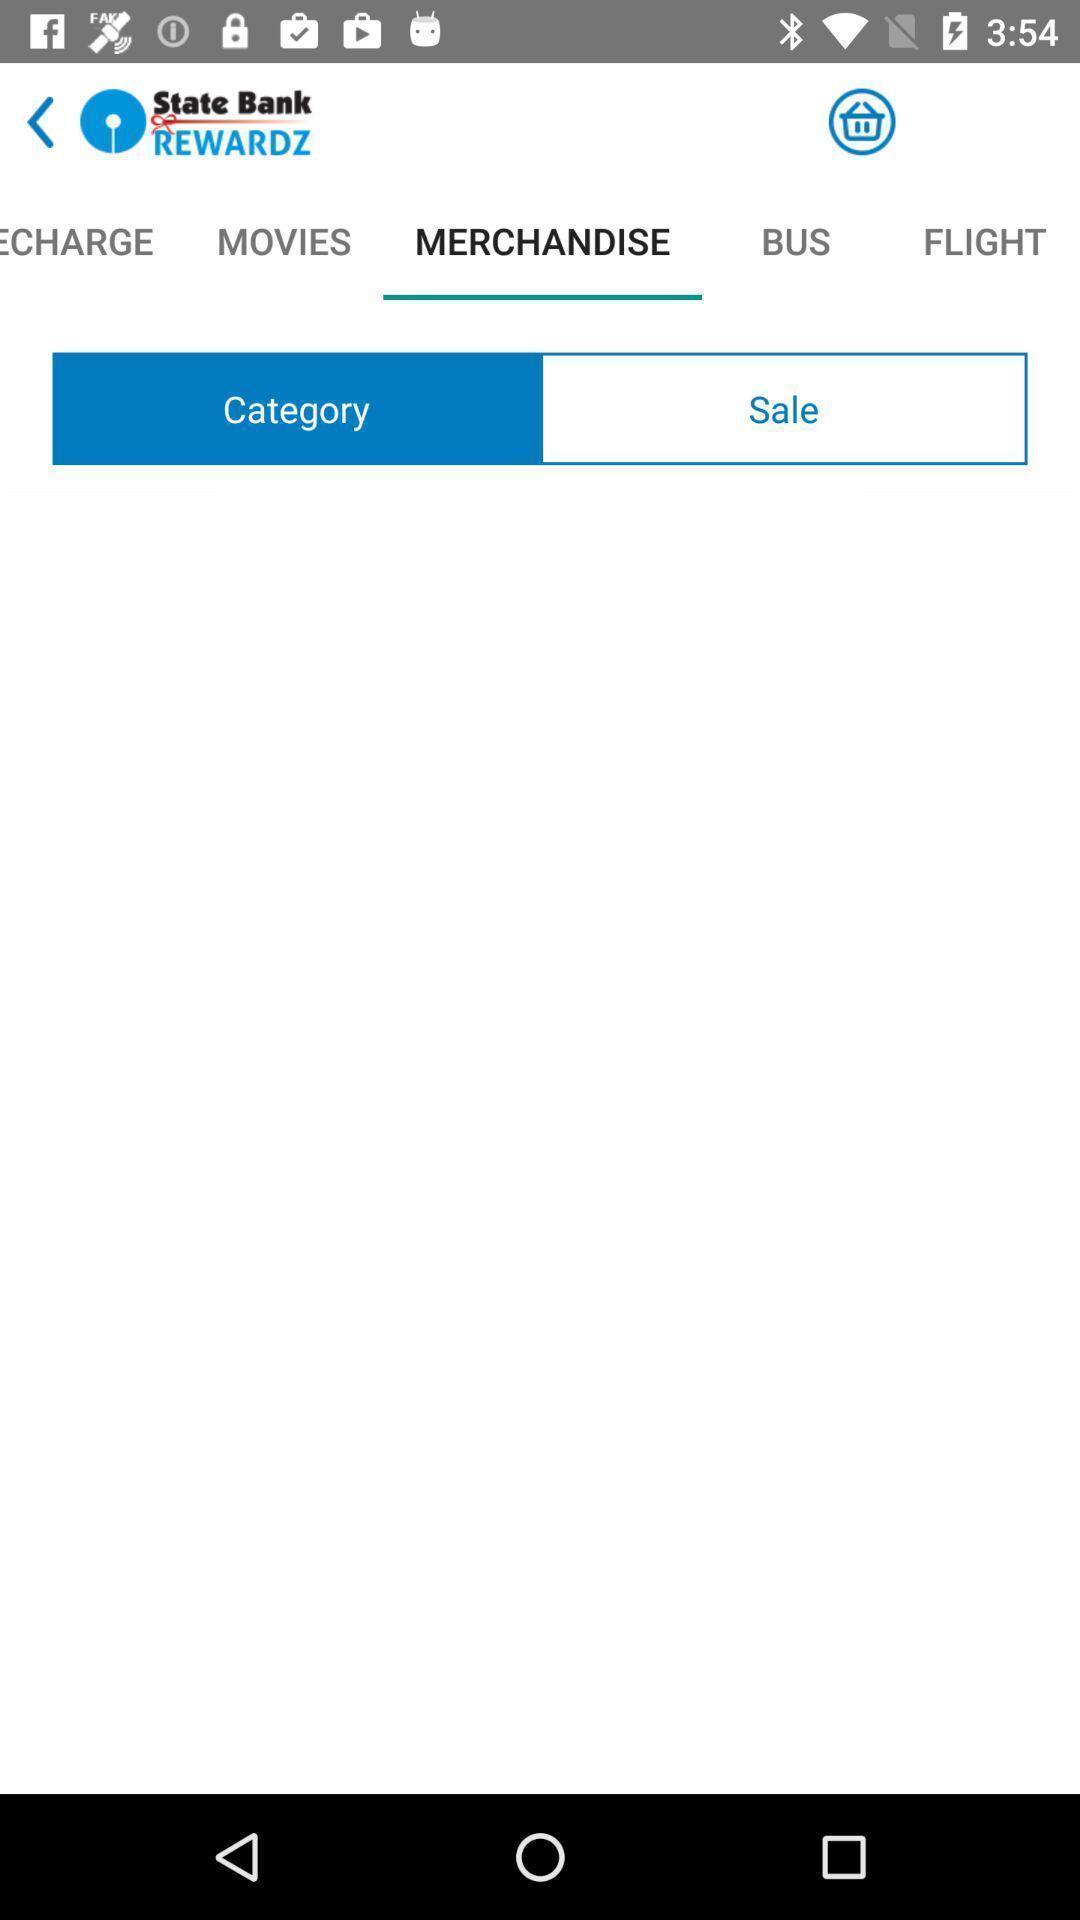What details can you identify in this image? Social app for showing list of merchandise. 